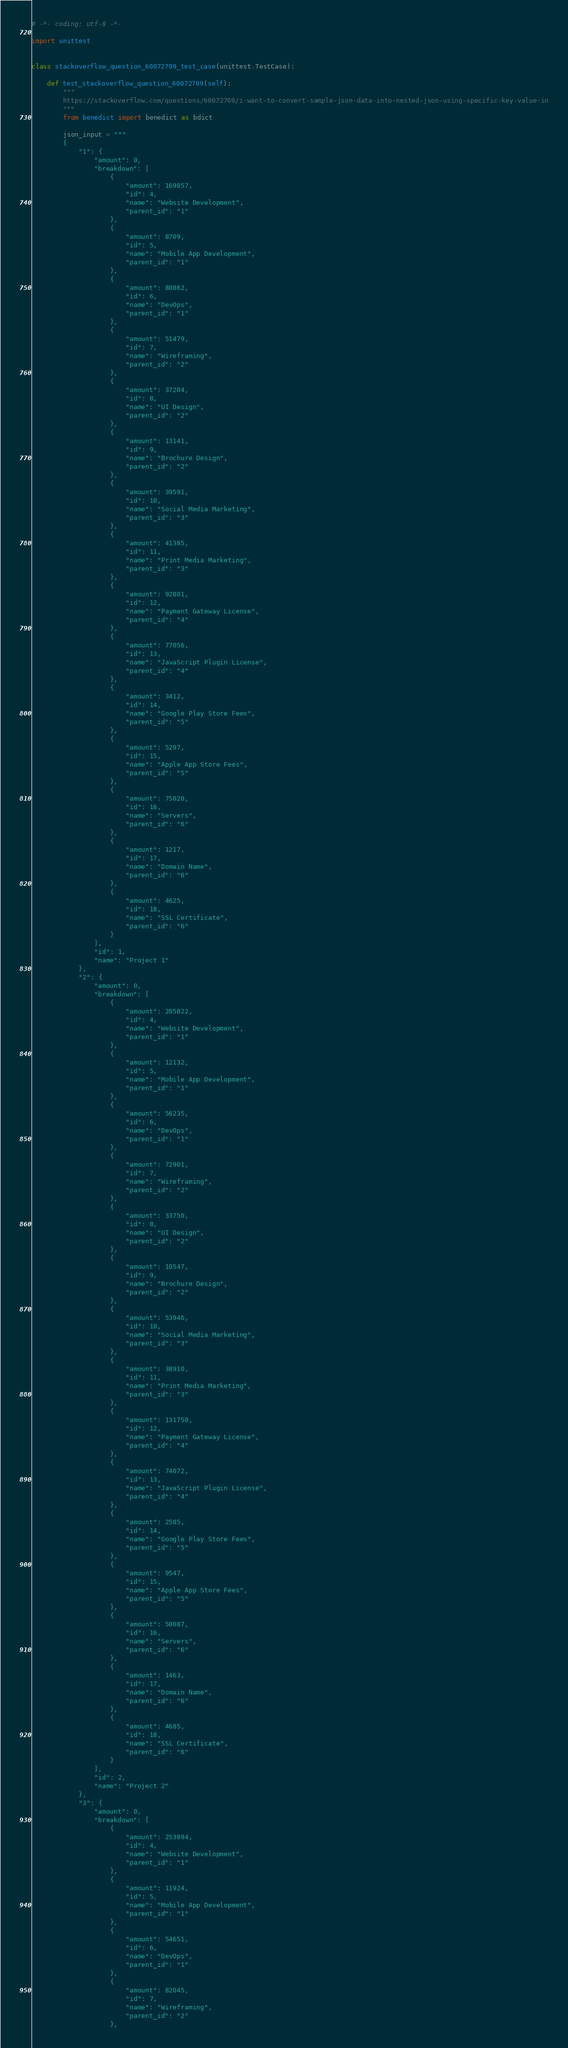<code> <loc_0><loc_0><loc_500><loc_500><_Python_># -*- coding: utf-8 -*-

import unittest


class stackoverflow_question_60072709_test_case(unittest.TestCase):

    def test_stackoverflow_question_60072709(self):
        """
        https://stackoverflow.com/questions/60072709/i-want-to-convert-sample-json-data-into-nested-json-using-specific-key-value-in
        """
        from benedict import benedict as bdict

        json_input = """
        {
            "1": {
                "amount": 0,
                "breakdown": [
                    {
                        "amount": 169857,
                        "id": 4,
                        "name": "Website Development",
                        "parent_id": "1"
                    },
                    {
                        "amount": 8709,
                        "id": 5,
                        "name": "Mobile App Development",
                        "parent_id": "1"
                    },
                    {
                        "amount": 80862,
                        "id": 6,
                        "name": "DevOps",
                        "parent_id": "1"
                    },
                    {
                        "amount": 51479,
                        "id": 7,
                        "name": "Wireframing",
                        "parent_id": "2"
                    },
                    {
                        "amount": 37204,
                        "id": 8,
                        "name": "UI Design",
                        "parent_id": "2"
                    },
                    {
                        "amount": 13141,
                        "id": 9,
                        "name": "Brochure Design",
                        "parent_id": "2"
                    },
                    {
                        "amount": 39591,
                        "id": 10,
                        "name": "Social Media Marketing",
                        "parent_id": "3"
                    },
                    {
                        "amount": 41385,
                        "id": 11,
                        "name": "Print Media Marketing",
                        "parent_id": "3"
                    },
                    {
                        "amount": 92801,
                        "id": 12,
                        "name": "Payment Gateway License",
                        "parent_id": "4"
                    },
                    {
                        "amount": 77056,
                        "id": 13,
                        "name": "JavaScript Plugin License",
                        "parent_id": "4"
                    },
                    {
                        "amount": 3412,
                        "id": 14,
                        "name": "Google Play Store Fees",
                        "parent_id": "5"
                    },
                    {
                        "amount": 5297,
                        "id": 15,
                        "name": "Apple App Store Fees",
                        "parent_id": "5"
                    },
                    {
                        "amount": 75020,
                        "id": 16,
                        "name": "Servers",
                        "parent_id": "6"
                    },
                    {
                        "amount": 1217,
                        "id": 17,
                        "name": "Domain Name",
                        "parent_id": "6"
                    },
                    {
                        "amount": 4625,
                        "id": 18,
                        "name": "SSL Certificate",
                        "parent_id": "6"
                    }
                ],
                "id": 1,
                "name": "Project 1"
            },
            "2": {
                "amount": 0,
                "breakdown": [
                    {
                        "amount": 205822,
                        "id": 4,
                        "name": "Website Development",
                        "parent_id": "1"
                    },
                    {
                        "amount": 12132,
                        "id": 5,
                        "name": "Mobile App Development",
                        "parent_id": "1"
                    },
                    {
                        "amount": 56235,
                        "id": 6,
                        "name": "DevOps",
                        "parent_id": "1"
                    },
                    {
                        "amount": 72901,
                        "id": 7,
                        "name": "Wireframing",
                        "parent_id": "2"
                    },
                    {
                        "amount": 33750,
                        "id": 8,
                        "name": "UI Design",
                        "parent_id": "2"
                    },
                    {
                        "amount": 10547,
                        "id": 9,
                        "name": "Brochure Design",
                        "parent_id": "2"
                    },
                    {
                        "amount": 53946,
                        "id": 10,
                        "name": "Social Media Marketing",
                        "parent_id": "3"
                    },
                    {
                        "amount": 38910,
                        "id": 11,
                        "name": "Print Media Marketing",
                        "parent_id": "3"
                    },
                    {
                        "amount": 131750,
                        "id": 12,
                        "name": "Payment Gateway License",
                        "parent_id": "4"
                    },
                    {
                        "amount": 74072,
                        "id": 13,
                        "name": "JavaScript Plugin License",
                        "parent_id": "4"
                    },
                    {
                        "amount": 2585,
                        "id": 14,
                        "name": "Google Play Store Fees",
                        "parent_id": "5"
                    },
                    {
                        "amount": 9547,
                        "id": 15,
                        "name": "Apple App Store Fees",
                        "parent_id": "5"
                    },
                    {
                        "amount": 50087,
                        "id": 16,
                        "name": "Servers",
                        "parent_id": "6"
                    },
                    {
                        "amount": 1463,
                        "id": 17,
                        "name": "Domain Name",
                        "parent_id": "6"
                    },
                    {
                        "amount": 4685,
                        "id": 18,
                        "name": "SSL Certificate",
                        "parent_id": "6"
                    }
                ],
                "id": 2,
                "name": "Project 2"
            },
            "3": {
                "amount": 0,
                "breakdown": [
                    {
                        "amount": 253894,
                        "id": 4,
                        "name": "Website Development",
                        "parent_id": "1"
                    },
                    {
                        "amount": 11924,
                        "id": 5,
                        "name": "Mobile App Development",
                        "parent_id": "1"
                    },
                    {
                        "amount": 54651,
                        "id": 6,
                        "name": "DevOps",
                        "parent_id": "1"
                    },
                    {
                        "amount": 82045,
                        "id": 7,
                        "name": "Wireframing",
                        "parent_id": "2"
                    },</code> 